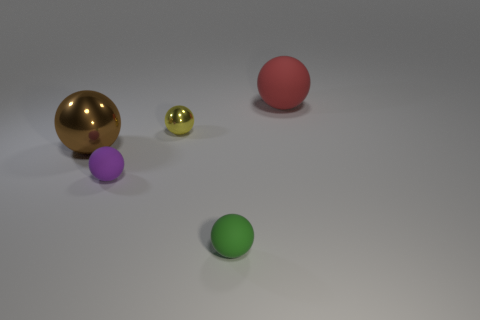Subtract all green matte balls. How many balls are left? 4 Subtract all green spheres. How many spheres are left? 4 Subtract 4 spheres. How many spheres are left? 1 Subtract all purple cubes. How many green spheres are left? 1 Add 3 small cyan blocks. How many objects exist? 8 Add 3 yellow things. How many yellow things are left? 4 Add 5 green things. How many green things exist? 6 Subtract 0 blue cylinders. How many objects are left? 5 Subtract all red balls. Subtract all brown cylinders. How many balls are left? 4 Subtract all large red blocks. Subtract all large brown shiny objects. How many objects are left? 4 